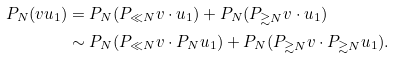<formula> <loc_0><loc_0><loc_500><loc_500>P _ { N } ( v u _ { 1 } ) & = P _ { N } ( P _ { \ll N } v \cdot u _ { 1 } ) + P _ { N } ( P _ { \gtrsim N } v \cdot u _ { 1 } ) \\ & \sim P _ { N } ( P _ { \ll N } v \cdot P _ { N } u _ { 1 } ) + P _ { N } ( P _ { \gtrsim N } v \cdot P _ { \gtrsim N } u _ { 1 } ) .</formula> 